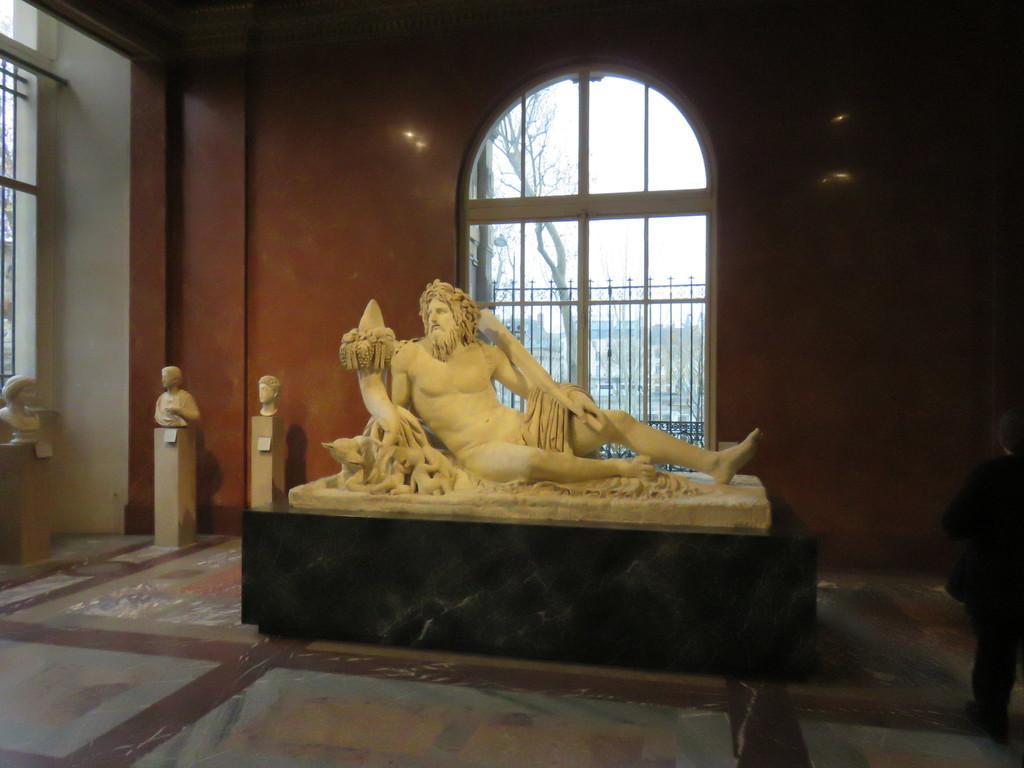Can you describe this image briefly? In this image I can see a person sculpture visible on the stone and I can see inside view of a room and I can see window in the middle through window I can see fence and tree and the sky , on the left side I can see a small sculpture 